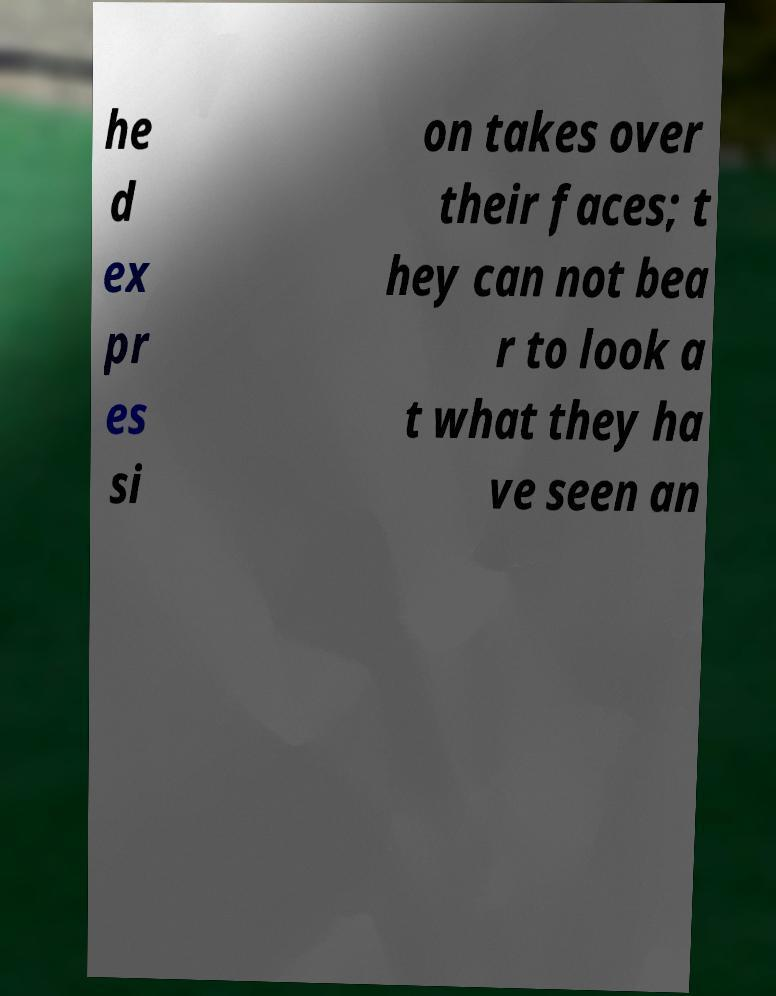There's text embedded in this image that I need extracted. Can you transcribe it verbatim? he d ex pr es si on takes over their faces; t hey can not bea r to look a t what they ha ve seen an 